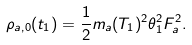<formula> <loc_0><loc_0><loc_500><loc_500>\rho _ { a , 0 } ( t _ { 1 } ) = \frac { 1 } { 2 } m _ { a } ( T _ { 1 } ) ^ { 2 } \theta _ { 1 } ^ { 2 } F _ { a } ^ { 2 } .</formula> 